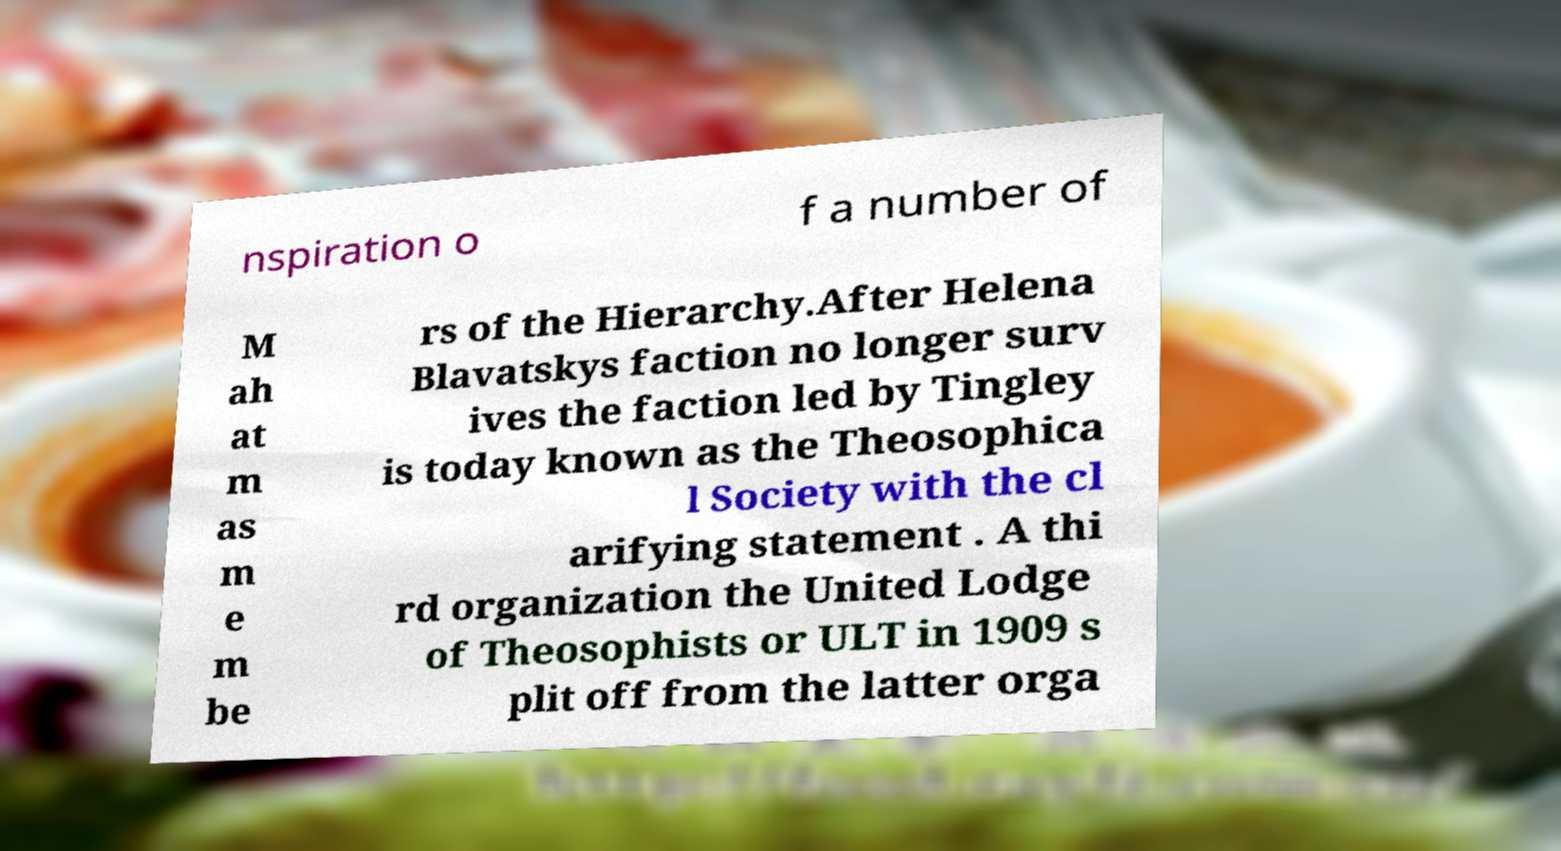Could you assist in decoding the text presented in this image and type it out clearly? nspiration o f a number of M ah at m as m e m be rs of the Hierarchy.After Helena Blavatskys faction no longer surv ives the faction led by Tingley is today known as the Theosophica l Society with the cl arifying statement . A thi rd organization the United Lodge of Theosophists or ULT in 1909 s plit off from the latter orga 